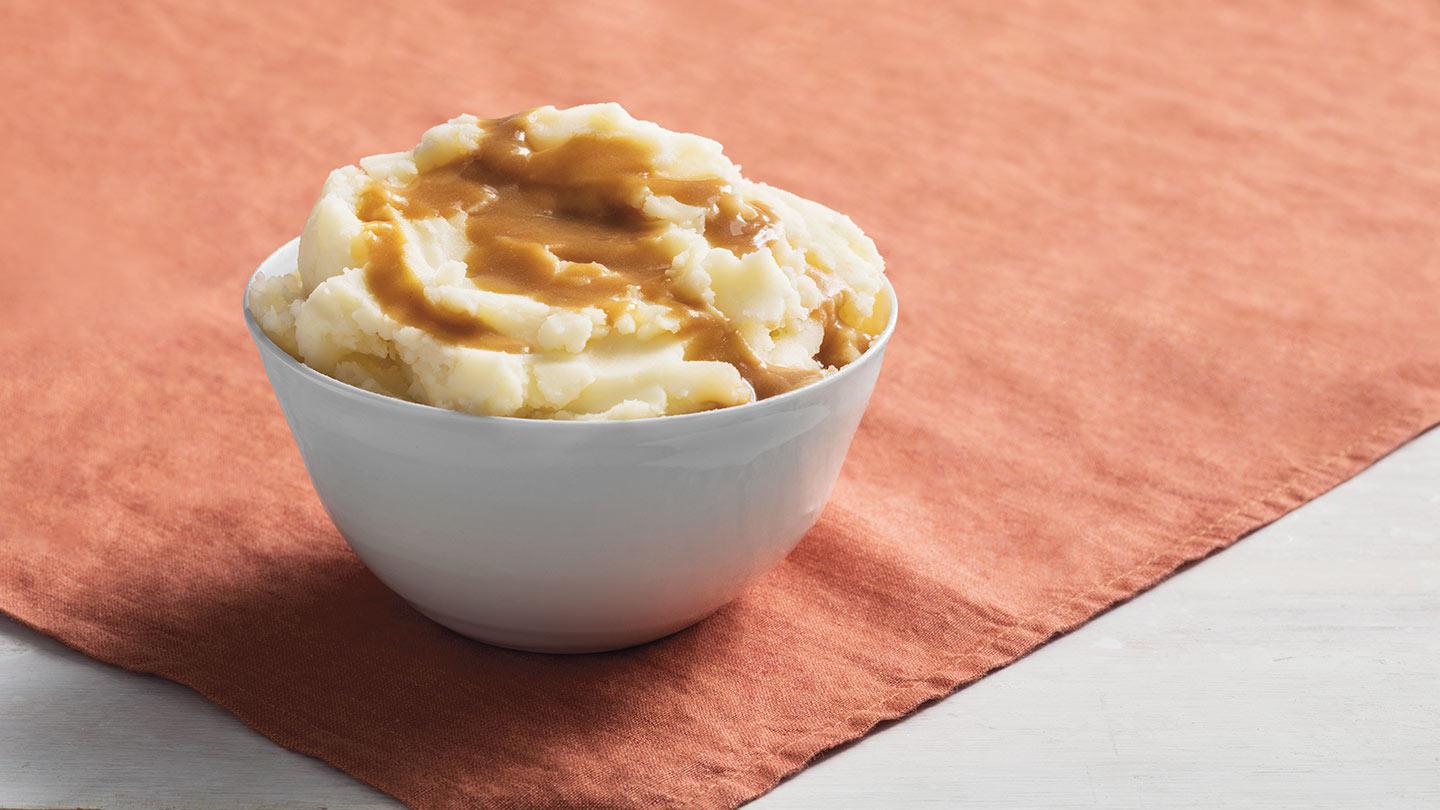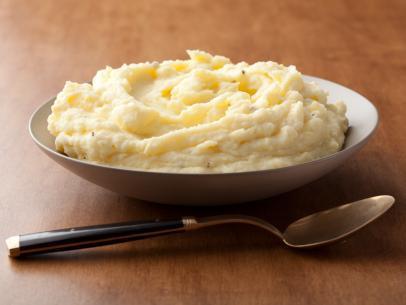The first image is the image on the left, the second image is the image on the right. Considering the images on both sides, is "There is a utensil in the right hand image." valid? Answer yes or no. Yes. The first image is the image on the left, the second image is the image on the right. Examine the images to the left and right. Is the description "The mashed potatoes on the right picture has a spoon in its container." accurate? Answer yes or no. No. 